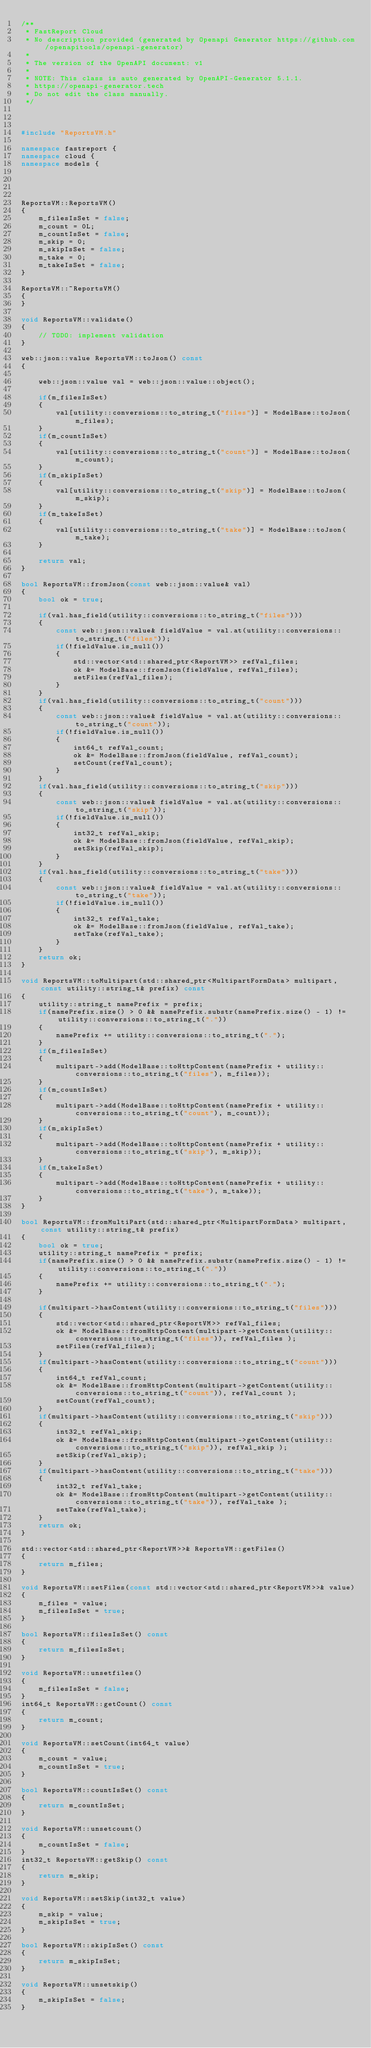<code> <loc_0><loc_0><loc_500><loc_500><_C++_>/**
 * FastReport Cloud
 * No description provided (generated by Openapi Generator https://github.com/openapitools/openapi-generator)
 *
 * The version of the OpenAPI document: v1
 *
 * NOTE: This class is auto generated by OpenAPI-Generator 5.1.1.
 * https://openapi-generator.tech
 * Do not edit the class manually.
 */



#include "ReportsVM.h"

namespace fastreport {
namespace cloud {
namespace models {




ReportsVM::ReportsVM()
{
    m_filesIsSet = false;
    m_count = 0L;
    m_countIsSet = false;
    m_skip = 0;
    m_skipIsSet = false;
    m_take = 0;
    m_takeIsSet = false;
}

ReportsVM::~ReportsVM()
{
}

void ReportsVM::validate()
{
    // TODO: implement validation
}

web::json::value ReportsVM::toJson() const
{

    web::json::value val = web::json::value::object();
    
    if(m_filesIsSet)
    {
        val[utility::conversions::to_string_t("files")] = ModelBase::toJson(m_files);
    }
    if(m_countIsSet)
    {
        val[utility::conversions::to_string_t("count")] = ModelBase::toJson(m_count);
    }
    if(m_skipIsSet)
    {
        val[utility::conversions::to_string_t("skip")] = ModelBase::toJson(m_skip);
    }
    if(m_takeIsSet)
    {
        val[utility::conversions::to_string_t("take")] = ModelBase::toJson(m_take);
    }

    return val;
}

bool ReportsVM::fromJson(const web::json::value& val)
{
    bool ok = true;
    
    if(val.has_field(utility::conversions::to_string_t("files")))
    {
        const web::json::value& fieldValue = val.at(utility::conversions::to_string_t("files"));
        if(!fieldValue.is_null())
        {
            std::vector<std::shared_ptr<ReportVM>> refVal_files;
            ok &= ModelBase::fromJson(fieldValue, refVal_files);
            setFiles(refVal_files);
        }
    }
    if(val.has_field(utility::conversions::to_string_t("count")))
    {
        const web::json::value& fieldValue = val.at(utility::conversions::to_string_t("count"));
        if(!fieldValue.is_null())
        {
            int64_t refVal_count;
            ok &= ModelBase::fromJson(fieldValue, refVal_count);
            setCount(refVal_count);
        }
    }
    if(val.has_field(utility::conversions::to_string_t("skip")))
    {
        const web::json::value& fieldValue = val.at(utility::conversions::to_string_t("skip"));
        if(!fieldValue.is_null())
        {
            int32_t refVal_skip;
            ok &= ModelBase::fromJson(fieldValue, refVal_skip);
            setSkip(refVal_skip);
        }
    }
    if(val.has_field(utility::conversions::to_string_t("take")))
    {
        const web::json::value& fieldValue = val.at(utility::conversions::to_string_t("take"));
        if(!fieldValue.is_null())
        {
            int32_t refVal_take;
            ok &= ModelBase::fromJson(fieldValue, refVal_take);
            setTake(refVal_take);
        }
    }
    return ok;
}

void ReportsVM::toMultipart(std::shared_ptr<MultipartFormData> multipart, const utility::string_t& prefix) const
{
    utility::string_t namePrefix = prefix;
    if(namePrefix.size() > 0 && namePrefix.substr(namePrefix.size() - 1) != utility::conversions::to_string_t("."))
    {
        namePrefix += utility::conversions::to_string_t(".");
    }
    if(m_filesIsSet)
    {
        multipart->add(ModelBase::toHttpContent(namePrefix + utility::conversions::to_string_t("files"), m_files));
    }
    if(m_countIsSet)
    {
        multipart->add(ModelBase::toHttpContent(namePrefix + utility::conversions::to_string_t("count"), m_count));
    }
    if(m_skipIsSet)
    {
        multipart->add(ModelBase::toHttpContent(namePrefix + utility::conversions::to_string_t("skip"), m_skip));
    }
    if(m_takeIsSet)
    {
        multipart->add(ModelBase::toHttpContent(namePrefix + utility::conversions::to_string_t("take"), m_take));
    }
}

bool ReportsVM::fromMultiPart(std::shared_ptr<MultipartFormData> multipart, const utility::string_t& prefix)
{
    bool ok = true;
    utility::string_t namePrefix = prefix;
    if(namePrefix.size() > 0 && namePrefix.substr(namePrefix.size() - 1) != utility::conversions::to_string_t("."))
    {
        namePrefix += utility::conversions::to_string_t(".");
    }

    if(multipart->hasContent(utility::conversions::to_string_t("files")))
    {
        std::vector<std::shared_ptr<ReportVM>> refVal_files;
        ok &= ModelBase::fromHttpContent(multipart->getContent(utility::conversions::to_string_t("files")), refVal_files );
        setFiles(refVal_files);
    }
    if(multipart->hasContent(utility::conversions::to_string_t("count")))
    {
        int64_t refVal_count;
        ok &= ModelBase::fromHttpContent(multipart->getContent(utility::conversions::to_string_t("count")), refVal_count );
        setCount(refVal_count);
    }
    if(multipart->hasContent(utility::conversions::to_string_t("skip")))
    {
        int32_t refVal_skip;
        ok &= ModelBase::fromHttpContent(multipart->getContent(utility::conversions::to_string_t("skip")), refVal_skip );
        setSkip(refVal_skip);
    }
    if(multipart->hasContent(utility::conversions::to_string_t("take")))
    {
        int32_t refVal_take;
        ok &= ModelBase::fromHttpContent(multipart->getContent(utility::conversions::to_string_t("take")), refVal_take );
        setTake(refVal_take);
    }
    return ok;
}

std::vector<std::shared_ptr<ReportVM>>& ReportsVM::getFiles()
{
    return m_files;
}

void ReportsVM::setFiles(const std::vector<std::shared_ptr<ReportVM>>& value)
{
    m_files = value;
    m_filesIsSet = true;
}

bool ReportsVM::filesIsSet() const
{
    return m_filesIsSet;
}

void ReportsVM::unsetfiles()
{
    m_filesIsSet = false;
}
int64_t ReportsVM::getCount() const
{
    return m_count;
}

void ReportsVM::setCount(int64_t value)
{
    m_count = value;
    m_countIsSet = true;
}

bool ReportsVM::countIsSet() const
{
    return m_countIsSet;
}

void ReportsVM::unsetcount()
{
    m_countIsSet = false;
}
int32_t ReportsVM::getSkip() const
{
    return m_skip;
}

void ReportsVM::setSkip(int32_t value)
{
    m_skip = value;
    m_skipIsSet = true;
}

bool ReportsVM::skipIsSet() const
{
    return m_skipIsSet;
}

void ReportsVM::unsetskip()
{
    m_skipIsSet = false;
}</code> 